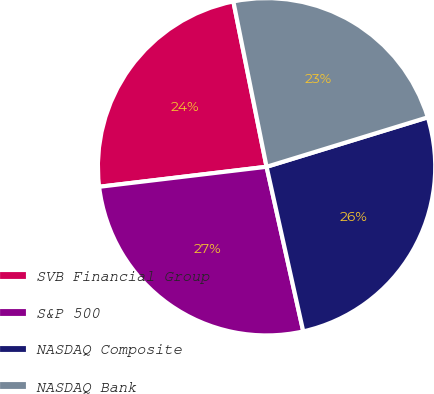<chart> <loc_0><loc_0><loc_500><loc_500><pie_chart><fcel>SVB Financial Group<fcel>S&P 500<fcel>NASDAQ Composite<fcel>NASDAQ Bank<nl><fcel>23.74%<fcel>26.6%<fcel>26.25%<fcel>23.42%<nl></chart> 